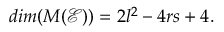Convert formula to latex. <formula><loc_0><loc_0><loc_500><loc_500>d i m ( M ( \mathcal { E } ) ) = 2 l ^ { 2 } - 4 r s + 4 .</formula> 